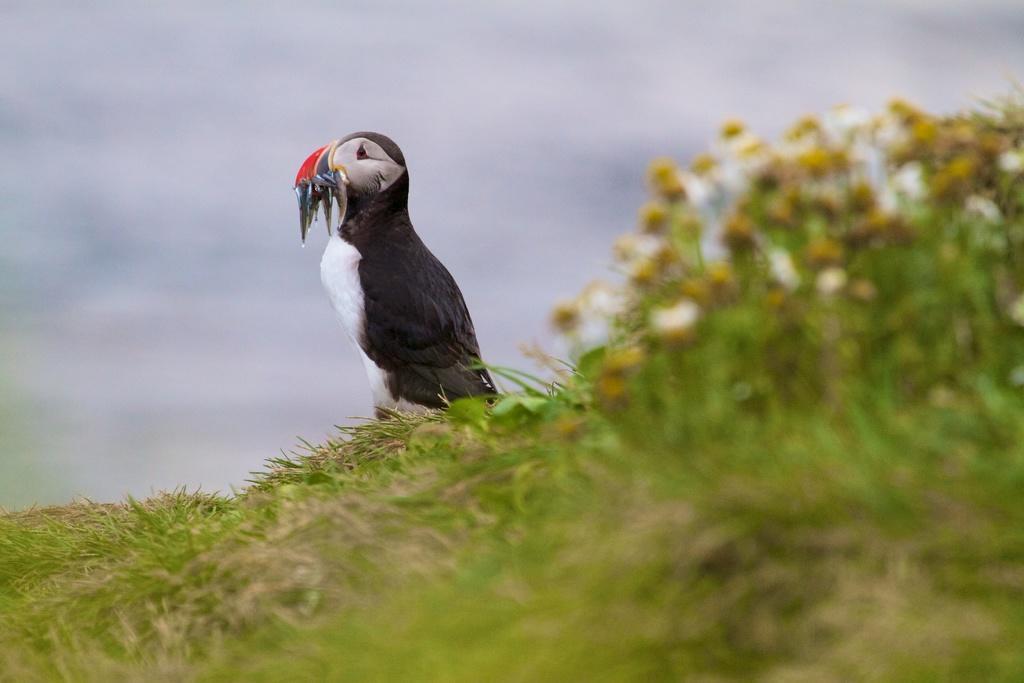Describe this image in one or two sentences. In this image, we can see a bird. At the bottom, there is a grass, plants with flowers. Background there is a sky. 